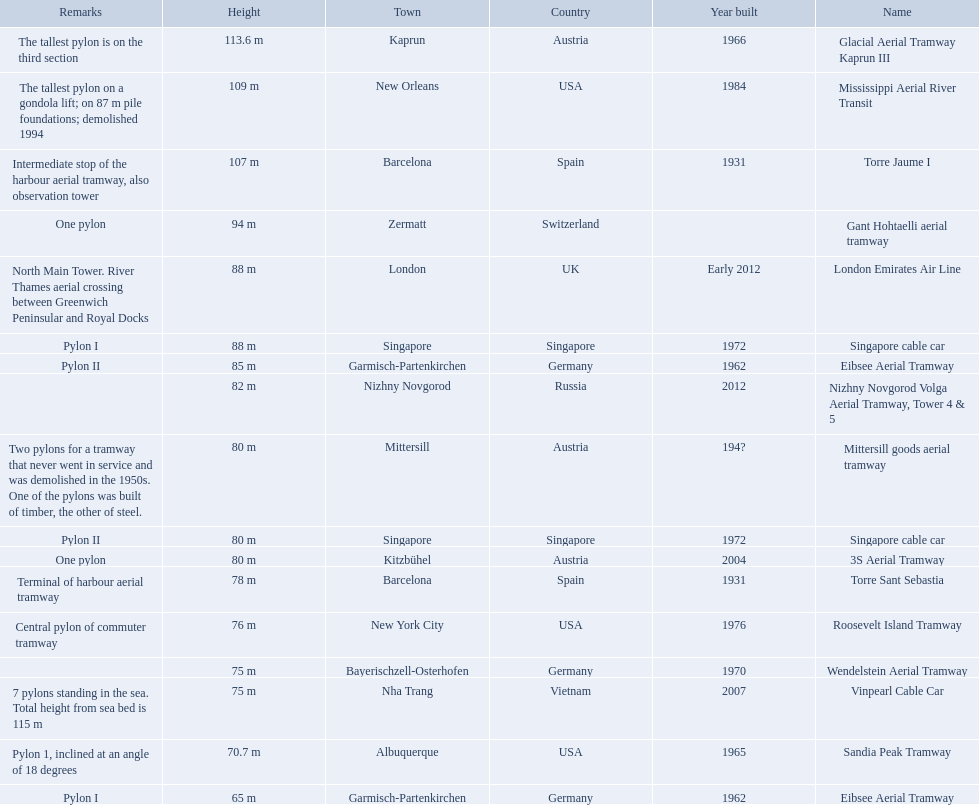How many aerial lift pylon's on the list are located in the usa? Mississippi Aerial River Transit, Roosevelt Island Tramway, Sandia Peak Tramway. Of the pylon's located in the usa how many were built after 1970? Mississippi Aerial River Transit, Roosevelt Island Tramway. Of the pylon's built after 1970 which is the tallest pylon on a gondola lift? Mississippi Aerial River Transit. Parse the full table. {'header': ['Remarks', 'Height', 'Town', 'Country', 'Year built', 'Name'], 'rows': [['The tallest pylon is on the third section', '113.6 m', 'Kaprun', 'Austria', '1966', 'Glacial Aerial Tramway Kaprun III'], ['The tallest pylon on a gondola lift; on 87 m pile foundations; demolished 1994', '109 m', 'New Orleans', 'USA', '1984', 'Mississippi Aerial River Transit'], ['Intermediate stop of the harbour aerial tramway, also observation tower', '107 m', 'Barcelona', 'Spain', '1931', 'Torre Jaume I'], ['One pylon', '94 m', 'Zermatt', 'Switzerland', '', 'Gant Hohtaelli aerial tramway'], ['North Main Tower. River Thames aerial crossing between Greenwich Peninsular and Royal Docks', '88 m', 'London', 'UK', 'Early 2012', 'London Emirates Air Line'], ['Pylon I', '88 m', 'Singapore', 'Singapore', '1972', 'Singapore cable car'], ['Pylon II', '85 m', 'Garmisch-Partenkirchen', 'Germany', '1962', 'Eibsee Aerial Tramway'], ['', '82 m', 'Nizhny Novgorod', 'Russia', '2012', 'Nizhny Novgorod Volga Aerial Tramway, Tower 4 & 5'], ['Two pylons for a tramway that never went in service and was demolished in the 1950s. One of the pylons was built of timber, the other of steel.', '80 m', 'Mittersill', 'Austria', '194?', 'Mittersill goods aerial tramway'], ['Pylon II', '80 m', 'Singapore', 'Singapore', '1972', 'Singapore cable car'], ['One pylon', '80 m', 'Kitzbühel', 'Austria', '2004', '3S Aerial Tramway'], ['Terminal of harbour aerial tramway', '78 m', 'Barcelona', 'Spain', '1931', 'Torre Sant Sebastia'], ['Central pylon of commuter tramway', '76 m', 'New York City', 'USA', '1976', 'Roosevelt Island Tramway'], ['', '75 m', 'Bayerischzell-Osterhofen', 'Germany', '1970', 'Wendelstein Aerial Tramway'], ['7 pylons standing in the sea. Total height from sea bed is 115 m', '75 m', 'Nha Trang', 'Vietnam', '2007', 'Vinpearl Cable Car'], ['Pylon 1, inclined at an angle of 18 degrees', '70.7 m', 'Albuquerque', 'USA', '1965', 'Sandia Peak Tramway'], ['Pylon I', '65 m', 'Garmisch-Partenkirchen', 'Germany', '1962', 'Eibsee Aerial Tramway']]} How many meters is the tallest pylon on a gondola lift? 109 m. Which aerial lifts are over 100 meters tall? Glacial Aerial Tramway Kaprun III, Mississippi Aerial River Transit, Torre Jaume I. Which of those was built last? Mississippi Aerial River Transit. And what is its total height? 109 m. Which lift has the second highest height? Mississippi Aerial River Transit. What is the value of the height? 109 m. 